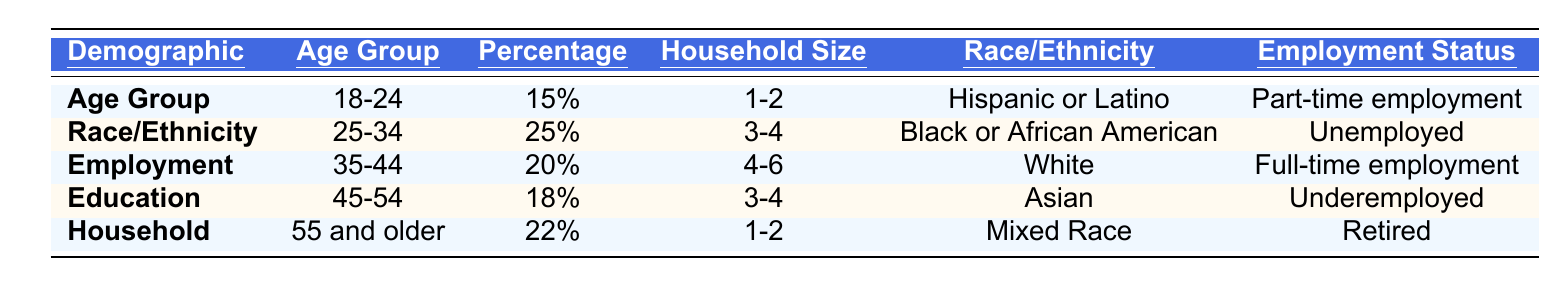What is the percentage of the age group 25-34? The age group 25-34 has a percentage value listed in the table under the "Percentage" column, which corresponds to that age group. It shows 25%.
Answer: 25% How many households are in the age group 35-44? The table states the household size for the age group 35-44 under the "Household Size" column, which is "4-6".
Answer: 4-6 Which race/ethnicity has the highest percentage? By comparing the percentages of all demographic groups listed, the age group 25-34 has the highest percentage at 25%.
Answer: Black or African American Is there an age group with a percentage less than 20? Looking through the table, the age groups 18-24 and 45-54 both have percentages of 15% and 18%, respectively, which are less than 20%.
Answer: Yes What is the average percentage of the age groups 45-54 and 55 and older? To find the average, we add the percentages of the two age groups (18% + 22% = 40%) and then divide by the number of groups (2). So, 40% / 2 = 20%.
Answer: 20% How many age groups have a majority living in a household size of 1-2? By reviewing the "Household Size" column, there are two age groups (18-24 and 55 and older) listed as living in a household size of 1-2.
Answer: 2 Which age group is most likely to be unemployed based on this data? Referring to the "Employment Status" column, we see that the age group 25-34 is listed as "Unemployed".
Answer: 25-34 What is the difference in percentage between the youngest and oldest age groups? The youngest age group (18-24) has a percentage of 15%, and the oldest (55 and older) has a percentage of 22%. The difference is calculated as 22% - 15% = 7%.
Answer: 7% How many age groups are represented in the table? By counting each age group listed in the "Age Group" column, there are five distinct age groups.
Answer: 5 Is full-time employment most common in the age group 35-44? According to the "Employment Status" column, full-time employment is listed for the age group 35-44, and no other age group shows a higher employment status.
Answer: Yes 